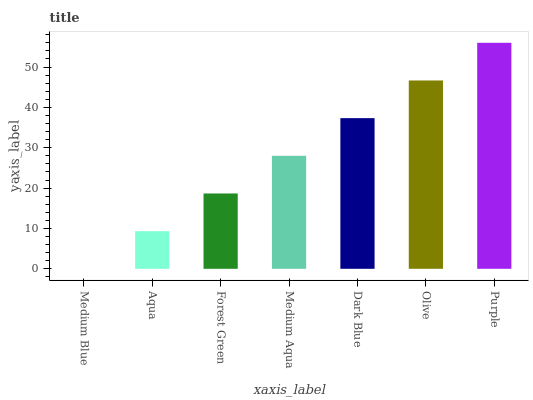Is Aqua the minimum?
Answer yes or no. No. Is Aqua the maximum?
Answer yes or no. No. Is Aqua greater than Medium Blue?
Answer yes or no. Yes. Is Medium Blue less than Aqua?
Answer yes or no. Yes. Is Medium Blue greater than Aqua?
Answer yes or no. No. Is Aqua less than Medium Blue?
Answer yes or no. No. Is Medium Aqua the high median?
Answer yes or no. Yes. Is Medium Aqua the low median?
Answer yes or no. Yes. Is Forest Green the high median?
Answer yes or no. No. Is Dark Blue the low median?
Answer yes or no. No. 